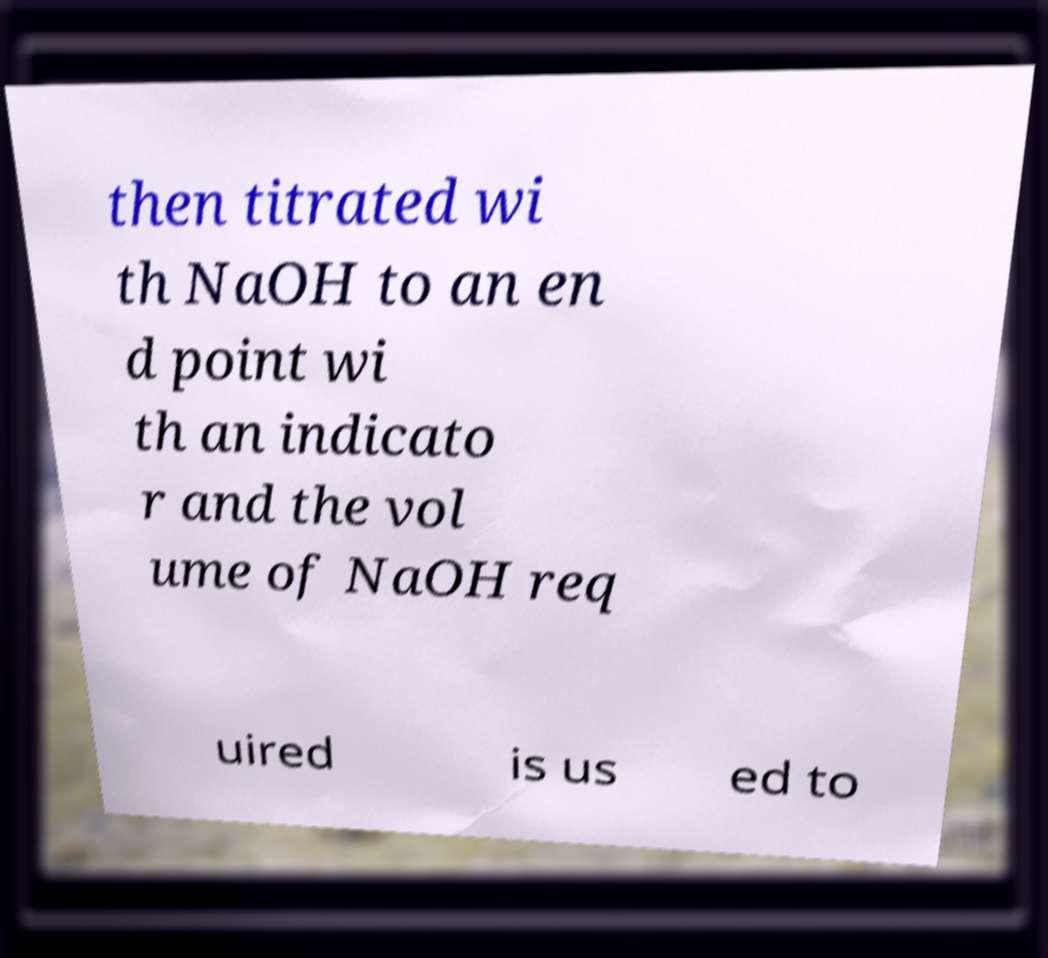I need the written content from this picture converted into text. Can you do that? then titrated wi th NaOH to an en d point wi th an indicato r and the vol ume of NaOH req uired is us ed to 